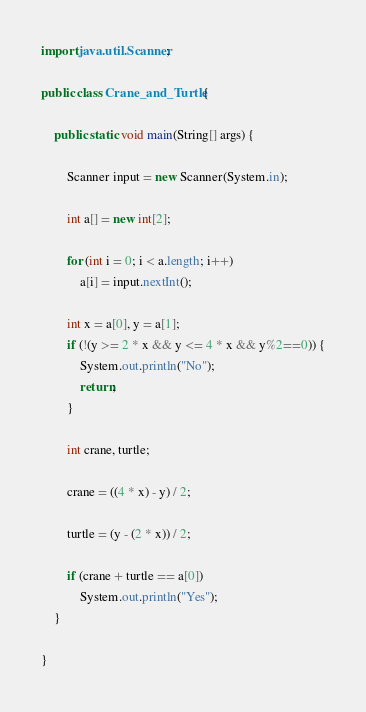<code> <loc_0><loc_0><loc_500><loc_500><_Java_>import java.util.Scanner;

public class Crane_and_Turtle {

	public static void main(String[] args) {

		Scanner input = new Scanner(System.in);

		int a[] = new int[2];

		for (int i = 0; i < a.length; i++)
			a[i] = input.nextInt();

		int x = a[0], y = a[1];
		if (!(y >= 2 * x && y <= 4 * x && y%2==0)) {
			System.out.println("No");
			return;
		}

		int crane, turtle;

		crane = ((4 * x) - y) / 2;

		turtle = (y - (2 * x)) / 2;

		if (crane + turtle == a[0])
			System.out.println("Yes");
	}

}
</code> 